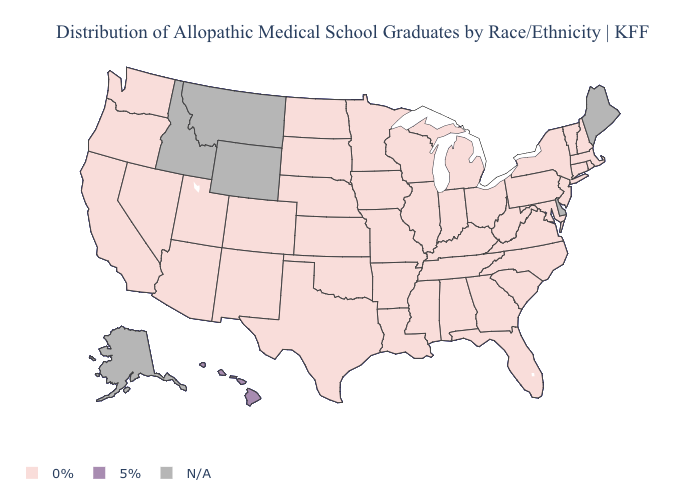Name the states that have a value in the range 0%?
Write a very short answer. Alabama, Arizona, Arkansas, California, Colorado, Connecticut, Florida, Georgia, Illinois, Indiana, Iowa, Kansas, Kentucky, Louisiana, Maryland, Massachusetts, Michigan, Minnesota, Mississippi, Missouri, Nebraska, Nevada, New Hampshire, New Jersey, New Mexico, New York, North Carolina, North Dakota, Ohio, Oklahoma, Oregon, Pennsylvania, Rhode Island, South Carolina, South Dakota, Tennessee, Texas, Utah, Vermont, Virginia, Washington, West Virginia, Wisconsin. Name the states that have a value in the range N/A?
Give a very brief answer. Alaska, Delaware, Idaho, Maine, Montana, Wyoming. Name the states that have a value in the range N/A?
Short answer required. Alaska, Delaware, Idaho, Maine, Montana, Wyoming. Which states have the lowest value in the South?
Short answer required. Alabama, Arkansas, Florida, Georgia, Kentucky, Louisiana, Maryland, Mississippi, North Carolina, Oklahoma, South Carolina, Tennessee, Texas, Virginia, West Virginia. Which states have the lowest value in the Northeast?
Keep it brief. Connecticut, Massachusetts, New Hampshire, New Jersey, New York, Pennsylvania, Rhode Island, Vermont. What is the highest value in the Northeast ?
Short answer required. 0%. Does Hawaii have the lowest value in the USA?
Keep it brief. No. What is the value of Georgia?
Quick response, please. 0%. What is the highest value in the West ?
Keep it brief. 5%. Which states have the lowest value in the USA?
Give a very brief answer. Alabama, Arizona, Arkansas, California, Colorado, Connecticut, Florida, Georgia, Illinois, Indiana, Iowa, Kansas, Kentucky, Louisiana, Maryland, Massachusetts, Michigan, Minnesota, Mississippi, Missouri, Nebraska, Nevada, New Hampshire, New Jersey, New Mexico, New York, North Carolina, North Dakota, Ohio, Oklahoma, Oregon, Pennsylvania, Rhode Island, South Carolina, South Dakota, Tennessee, Texas, Utah, Vermont, Virginia, Washington, West Virginia, Wisconsin. 